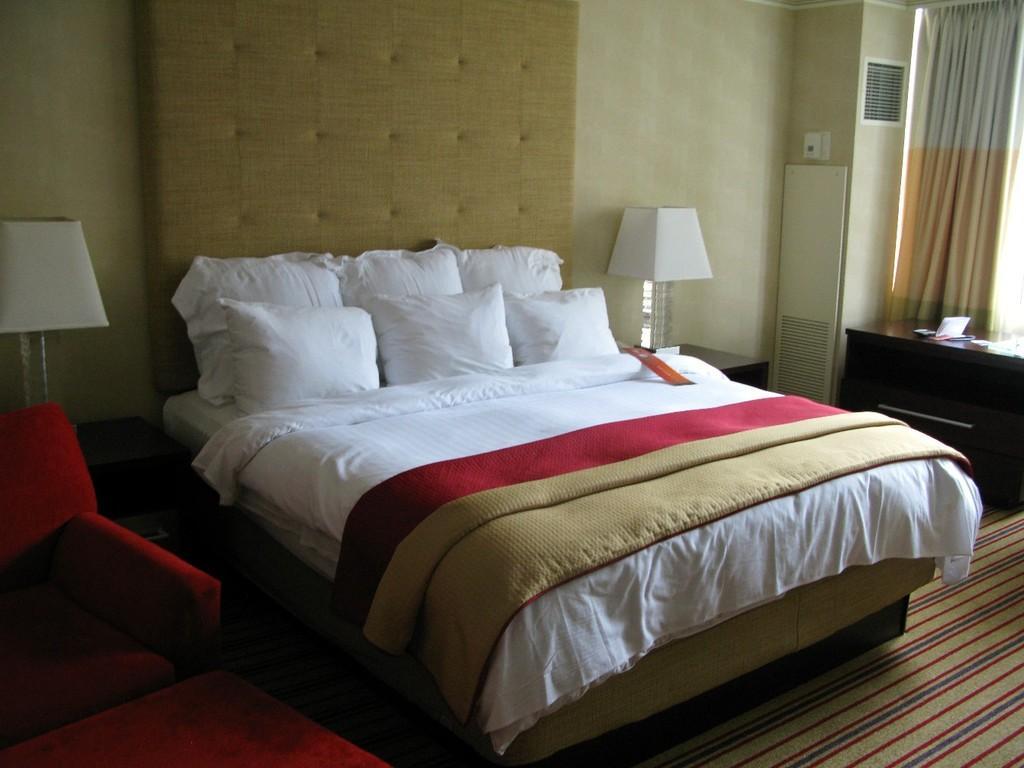Can you describe this image briefly? This picture shows a best andrew pillows and we see a lamp and a table 